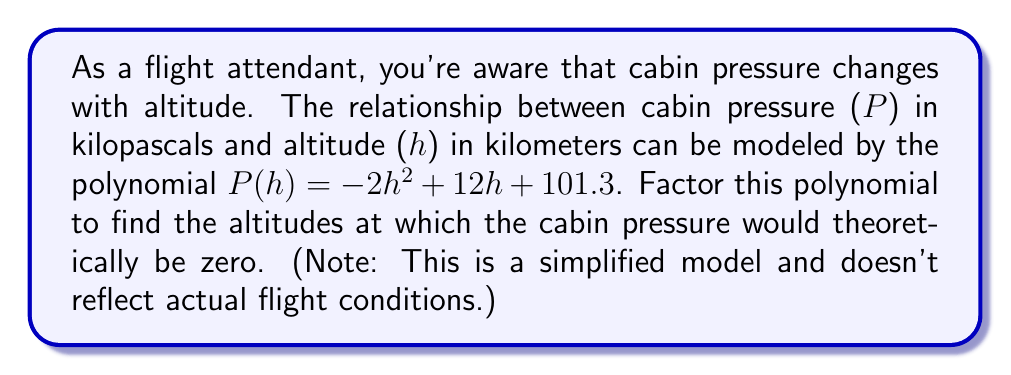Give your solution to this math problem. To solve this problem, we need to factor the polynomial $P(h) = -2h^2 + 12h + 101.3$ and find its roots. The roots of this polynomial will give us the altitudes at which the cabin pressure would theoretically be zero.

Step 1: Set the polynomial equal to zero.
$-2h^2 + 12h + 101.3 = 0$

Step 2: Multiply all terms by -1/2 to make the leading coefficient 1.
$h^2 - 6h - 50.65 = 0$

Step 3: Use the quadratic formula $h = \frac{-b \pm \sqrt{b^2 - 4ac}}{2a}$, where $a=1$, $b=-6$, and $c=-50.65$.

$h = \frac{6 \pm \sqrt{(-6)^2 - 4(1)(-50.65)}}{2(1)}$

$h = \frac{6 \pm \sqrt{36 + 202.6}}{2}$

$h = \frac{6 \pm \sqrt{238.6}}{2}$

$h = \frac{6 \pm 15.45}{2}$

Step 4: Calculate the two roots:

$h_1 = \frac{6 + 15.45}{2} = 10.725$ km

$h_2 = \frac{6 - 15.45}{2} = -4.725$ km

Step 5: Write the factored form of the polynomial:

$P(h) = -2(h - 10.725)(h + 4.725)$

The positive root (10.725 km) represents the theoretical altitude at which cabin pressure would be zero. The negative root (-4.725 km) is not physically meaningful in this context.
Answer: The factored form of the polynomial is $P(h) = -2(h - 10.725)(h + 4.725)$. The theoretical altitude at which cabin pressure would be zero is approximately 10.725 km. 